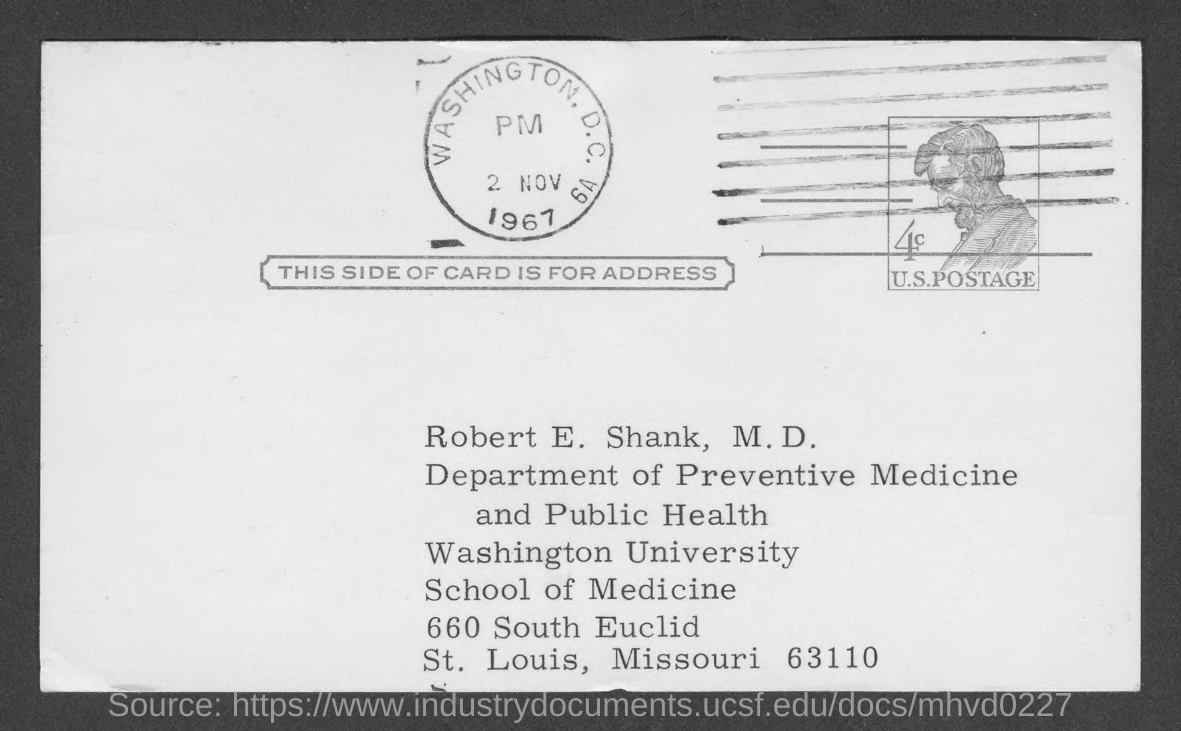What is the name mentioned in the given card ?
Ensure brevity in your answer.  ROBERT E. SHANK. What is the name of the department mentioned in the given card ?
Give a very brief answer. Department of preventive medicine and public health. What is the name of the university mentioned in the given form ?
Your response must be concise. Washington university. What is the date mentioned in the given page ?
Provide a short and direct response. 2 nov 1967. What does this side of the card shows ?
Keep it short and to the point. ADDRESS. 